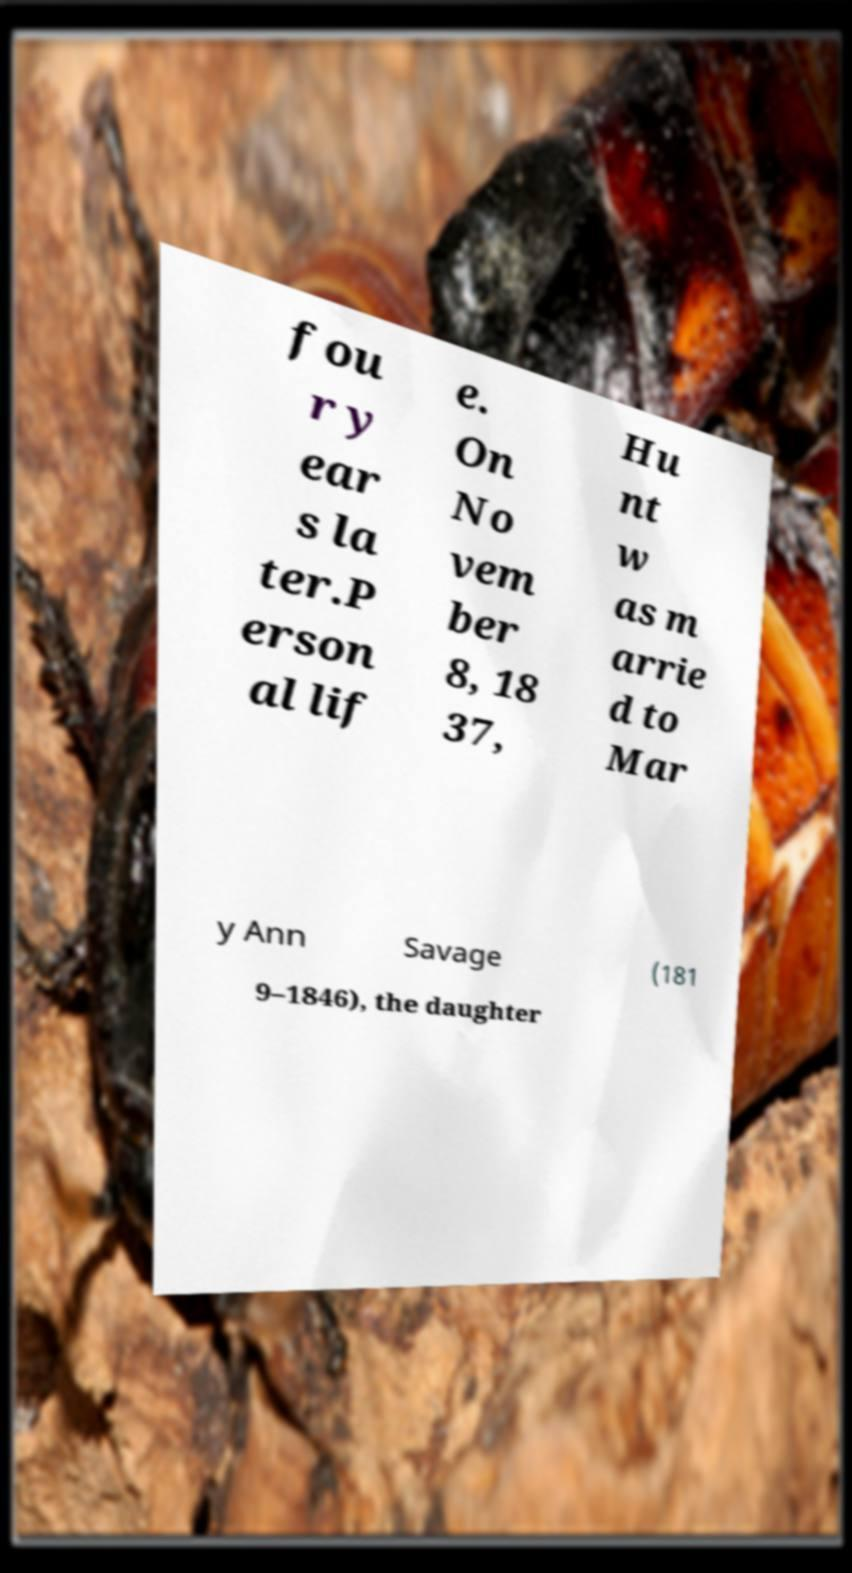There's text embedded in this image that I need extracted. Can you transcribe it verbatim? fou r y ear s la ter.P erson al lif e. On No vem ber 8, 18 37, Hu nt w as m arrie d to Mar y Ann Savage (181 9–1846), the daughter 